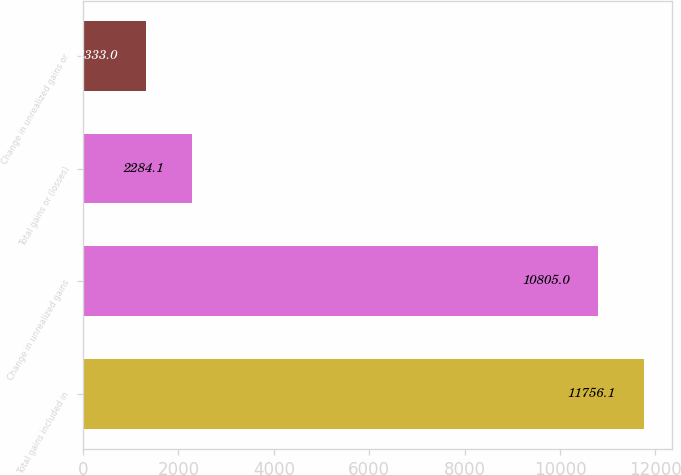<chart> <loc_0><loc_0><loc_500><loc_500><bar_chart><fcel>Total gains included in<fcel>Change in unrealized gains<fcel>Total gains or (losses)<fcel>Change in unrealized gains or<nl><fcel>11756.1<fcel>10805<fcel>2284.1<fcel>1333<nl></chart> 